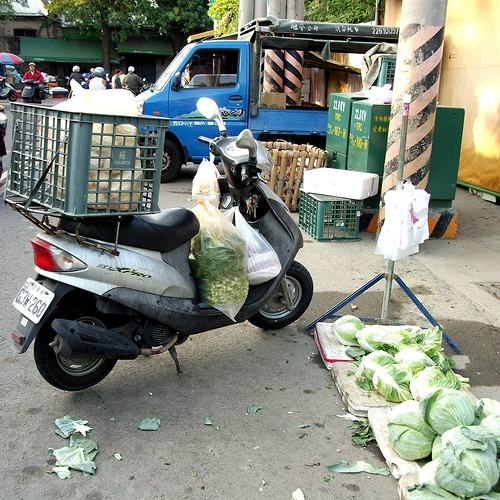Describe the objects in this image and their specific colors. I can see motorcycle in gray, black, darkgray, and white tones, truck in gray, black, blue, and white tones, motorcycle in gray, black, and darkgray tones, people in gray, black, darkgray, and white tones, and people in gray, white, and lightblue tones in this image. 